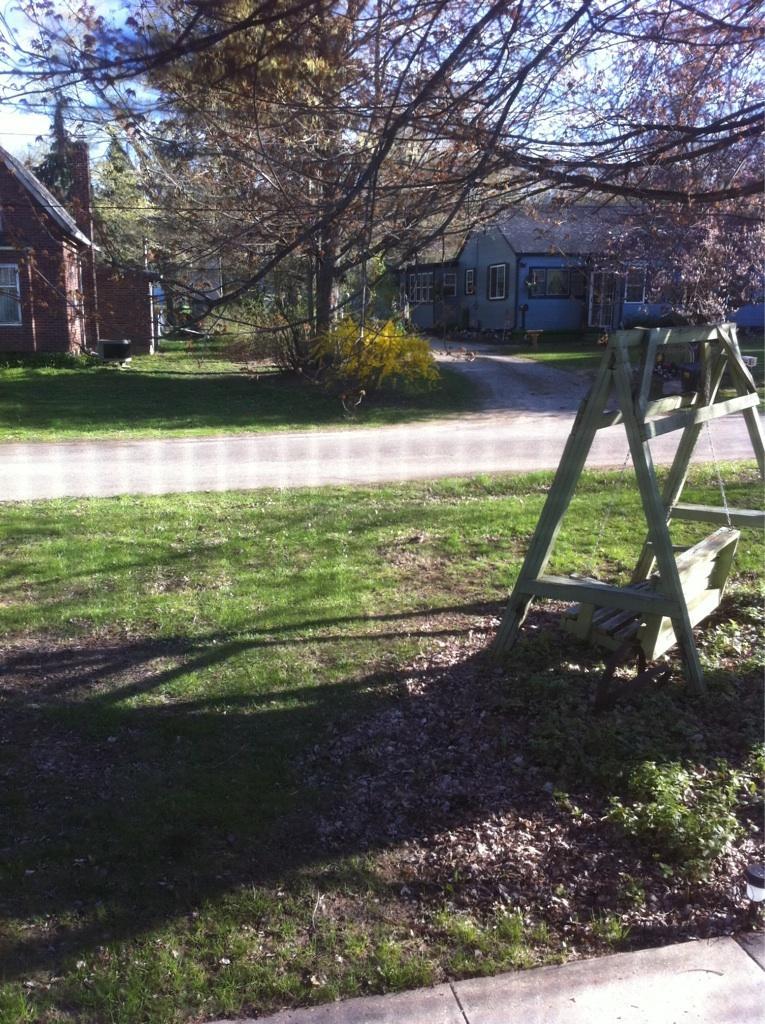Can you describe this image briefly? In this picture we can see grass, tree, swing and stand. In the background of the image we can see houses, grass, plants, trees and sky. 